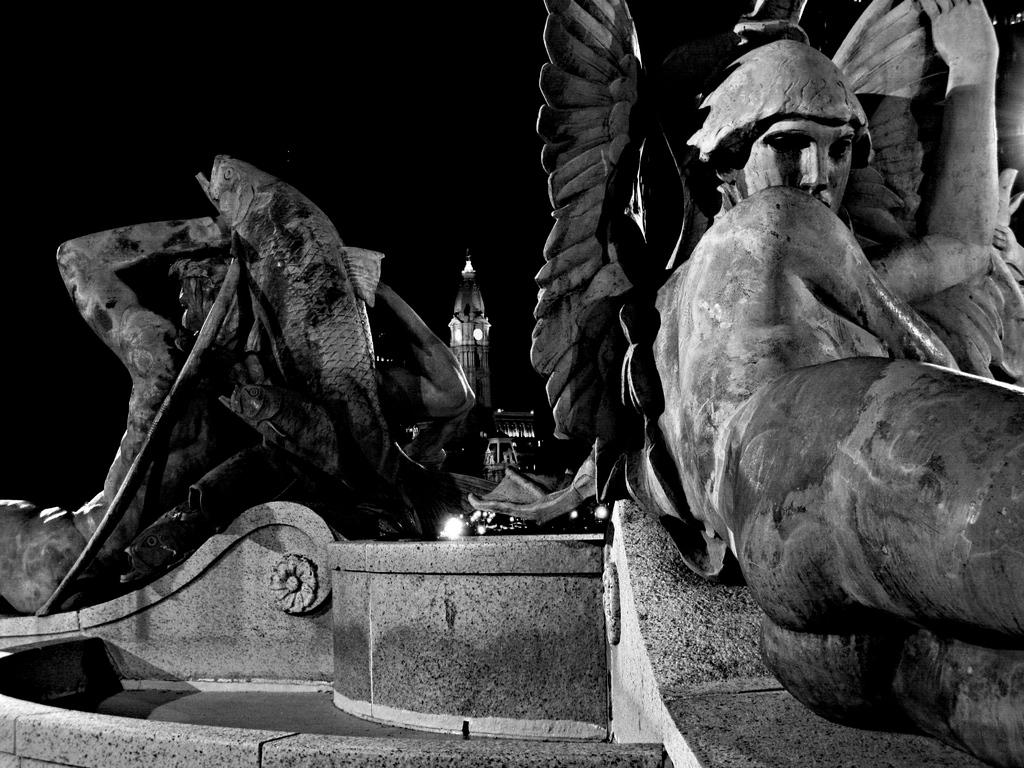What is the color scheme of the image? The image is black and white. What subjects are depicted in the image? There is a depiction of humans and fish in the image. What can be seen in the background of the image? There are lights and a tower building visible in the background of the image. What type of cabbage is being worn by the mom in the image? There is no mom or cabbage present in the image. What color is the sweater worn by the person in the image? The image is black and white, white, and shades of gray, so it is not possible to determine the color of any clothing. 